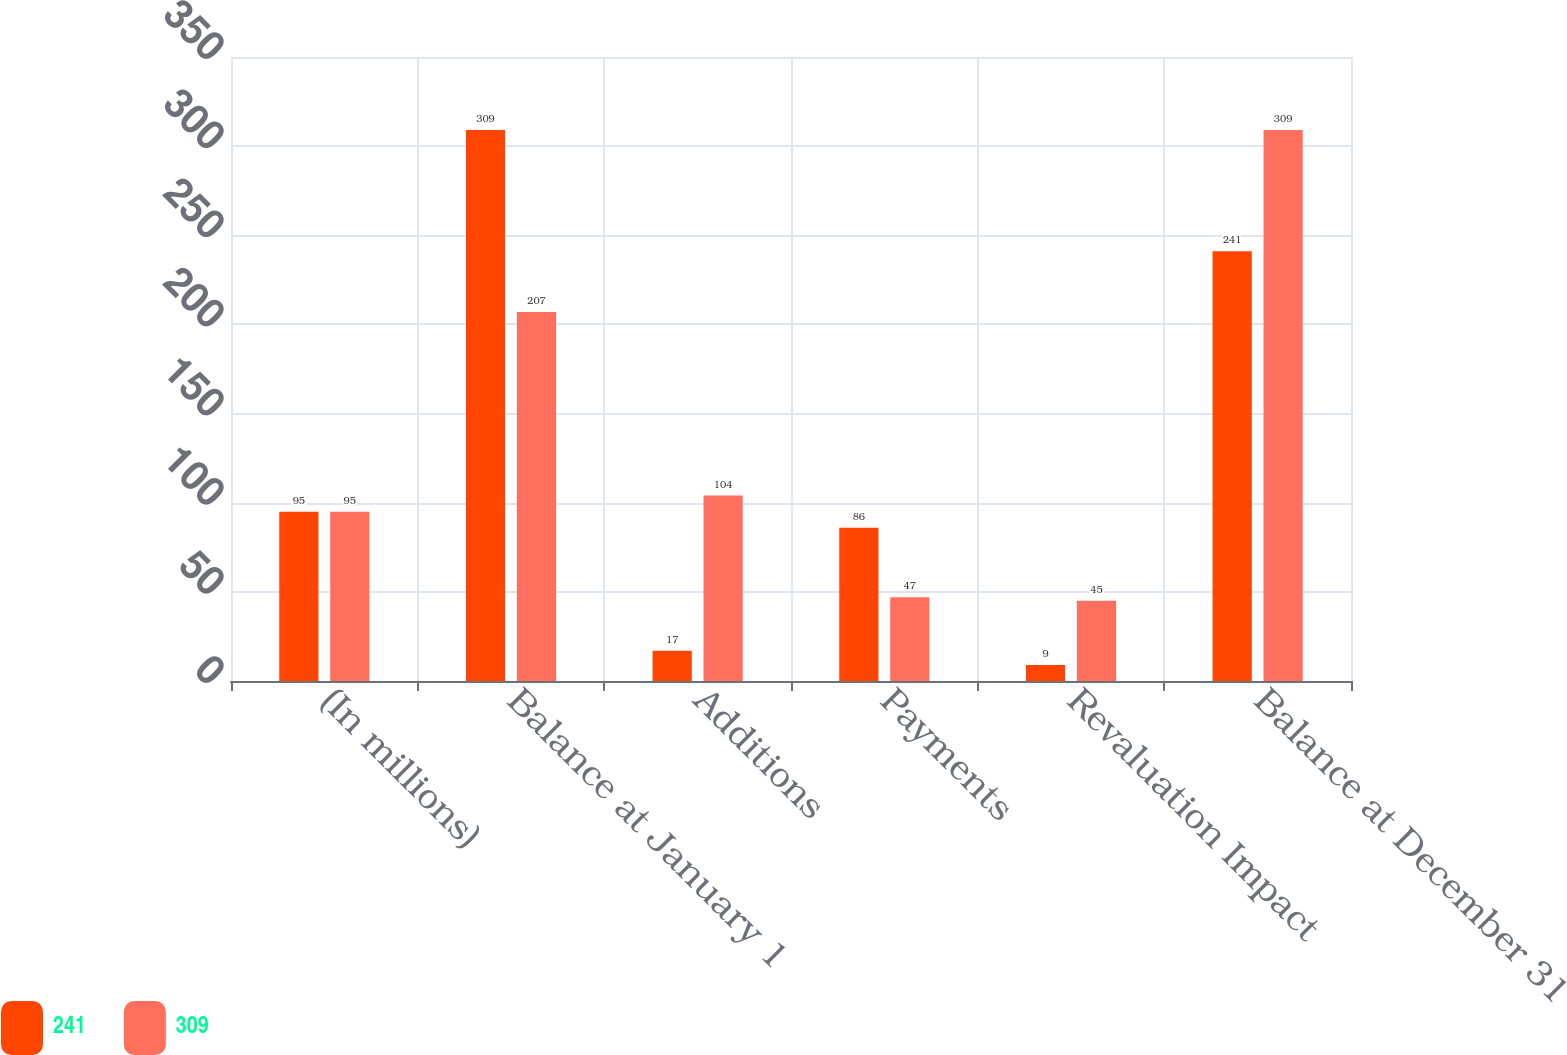<chart> <loc_0><loc_0><loc_500><loc_500><stacked_bar_chart><ecel><fcel>(In millions)<fcel>Balance at January 1<fcel>Additions<fcel>Payments<fcel>Revaluation Impact<fcel>Balance at December 31<nl><fcel>241<fcel>95<fcel>309<fcel>17<fcel>86<fcel>9<fcel>241<nl><fcel>309<fcel>95<fcel>207<fcel>104<fcel>47<fcel>45<fcel>309<nl></chart> 